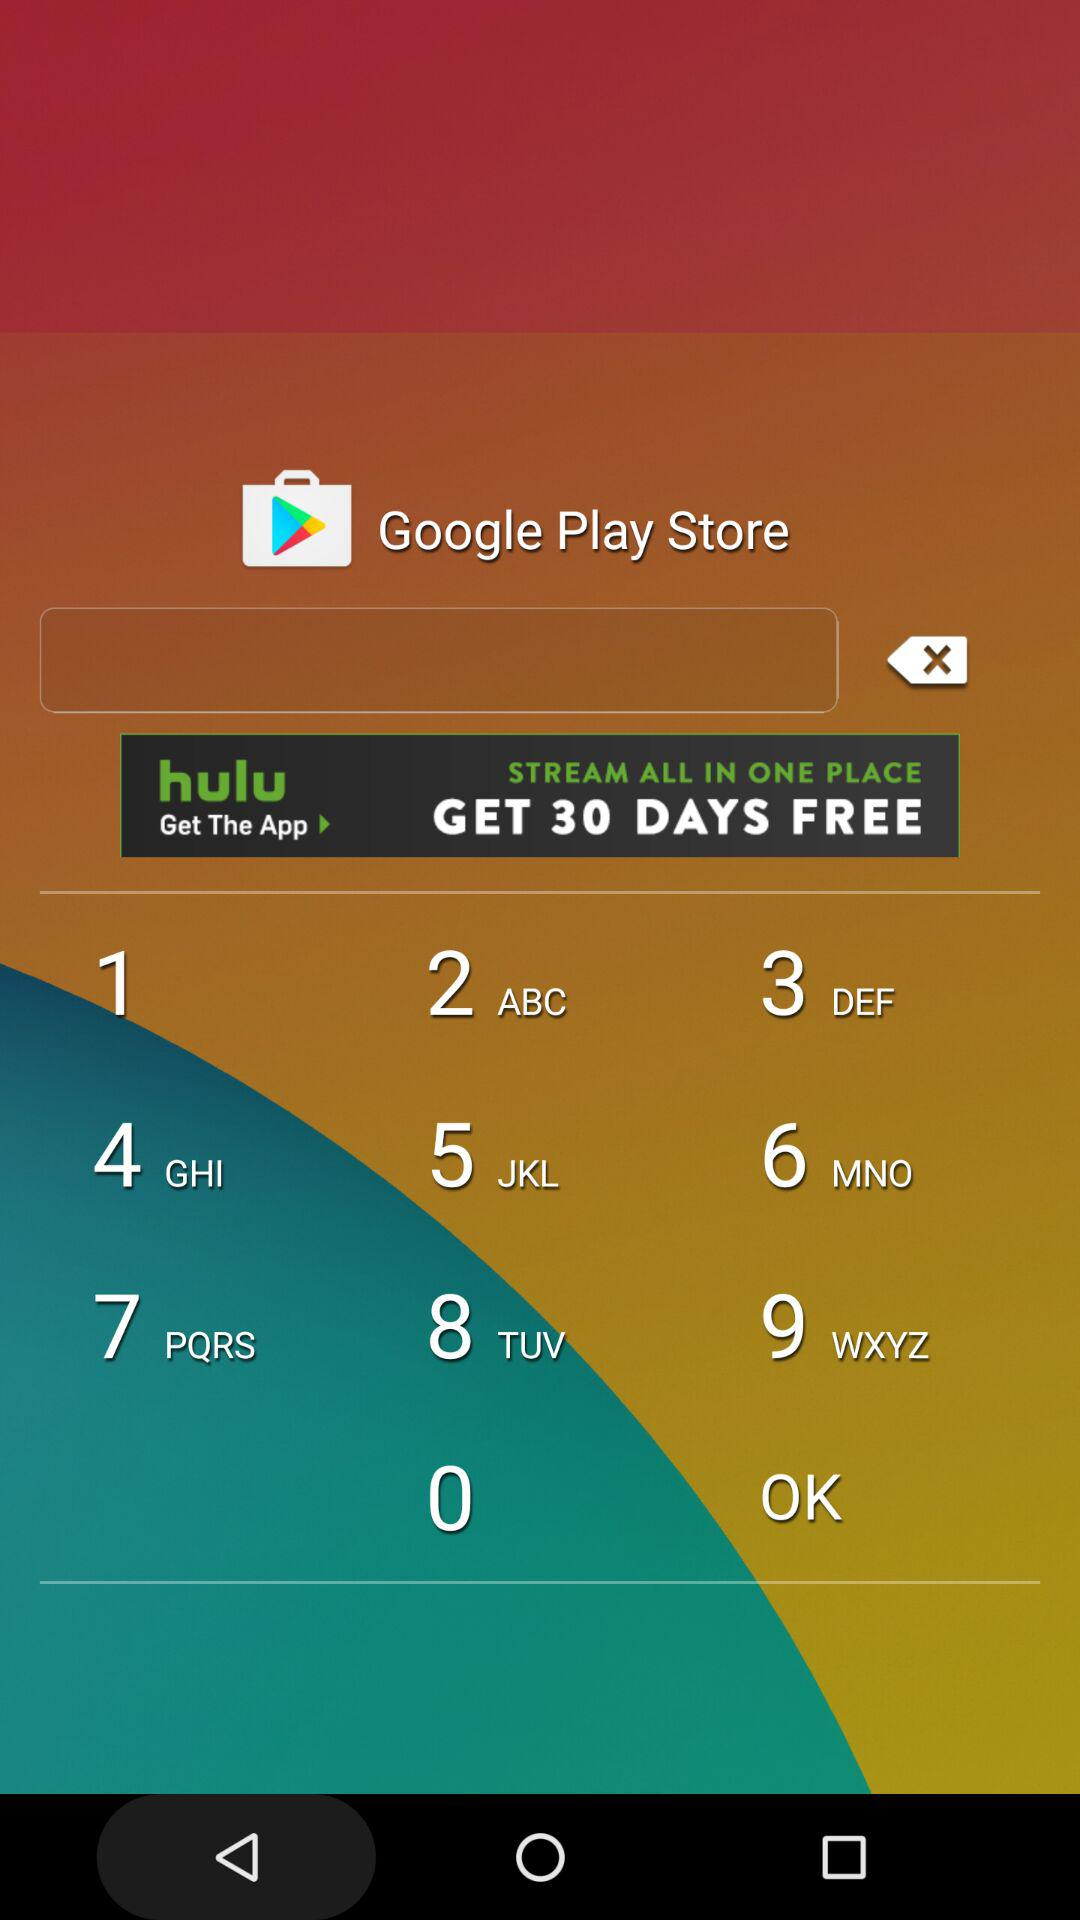What is the date of the "PARX RACING"? The date is March 27. 